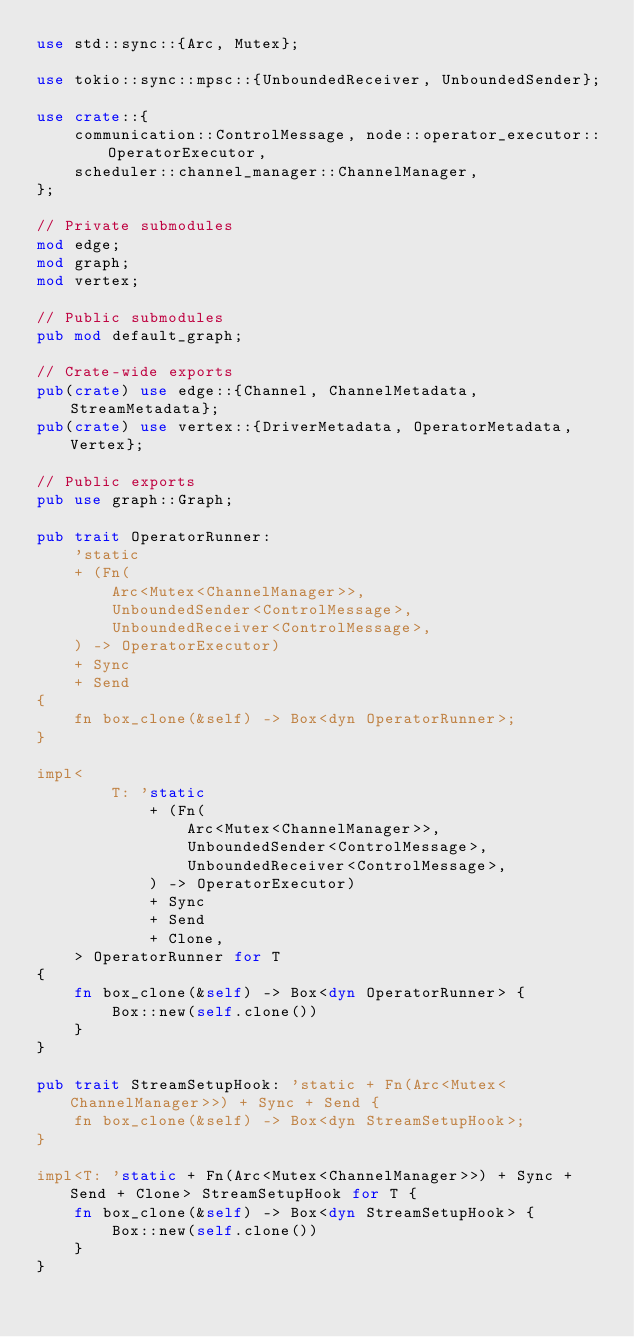Convert code to text. <code><loc_0><loc_0><loc_500><loc_500><_Rust_>use std::sync::{Arc, Mutex};

use tokio::sync::mpsc::{UnboundedReceiver, UnboundedSender};

use crate::{
    communication::ControlMessage, node::operator_executor::OperatorExecutor,
    scheduler::channel_manager::ChannelManager,
};

// Private submodules
mod edge;
mod graph;
mod vertex;

// Public submodules
pub mod default_graph;

// Crate-wide exports
pub(crate) use edge::{Channel, ChannelMetadata, StreamMetadata};
pub(crate) use vertex::{DriverMetadata, OperatorMetadata, Vertex};

// Public exports
pub use graph::Graph;

pub trait OperatorRunner:
    'static
    + (Fn(
        Arc<Mutex<ChannelManager>>,
        UnboundedSender<ControlMessage>,
        UnboundedReceiver<ControlMessage>,
    ) -> OperatorExecutor)
    + Sync
    + Send
{
    fn box_clone(&self) -> Box<dyn OperatorRunner>;
}

impl<
        T: 'static
            + (Fn(
                Arc<Mutex<ChannelManager>>,
                UnboundedSender<ControlMessage>,
                UnboundedReceiver<ControlMessage>,
            ) -> OperatorExecutor)
            + Sync
            + Send
            + Clone,
    > OperatorRunner for T
{
    fn box_clone(&self) -> Box<dyn OperatorRunner> {
        Box::new(self.clone())
    }
}

pub trait StreamSetupHook: 'static + Fn(Arc<Mutex<ChannelManager>>) + Sync + Send {
    fn box_clone(&self) -> Box<dyn StreamSetupHook>;
}

impl<T: 'static + Fn(Arc<Mutex<ChannelManager>>) + Sync + Send + Clone> StreamSetupHook for T {
    fn box_clone(&self) -> Box<dyn StreamSetupHook> {
        Box::new(self.clone())
    }
}
</code> 